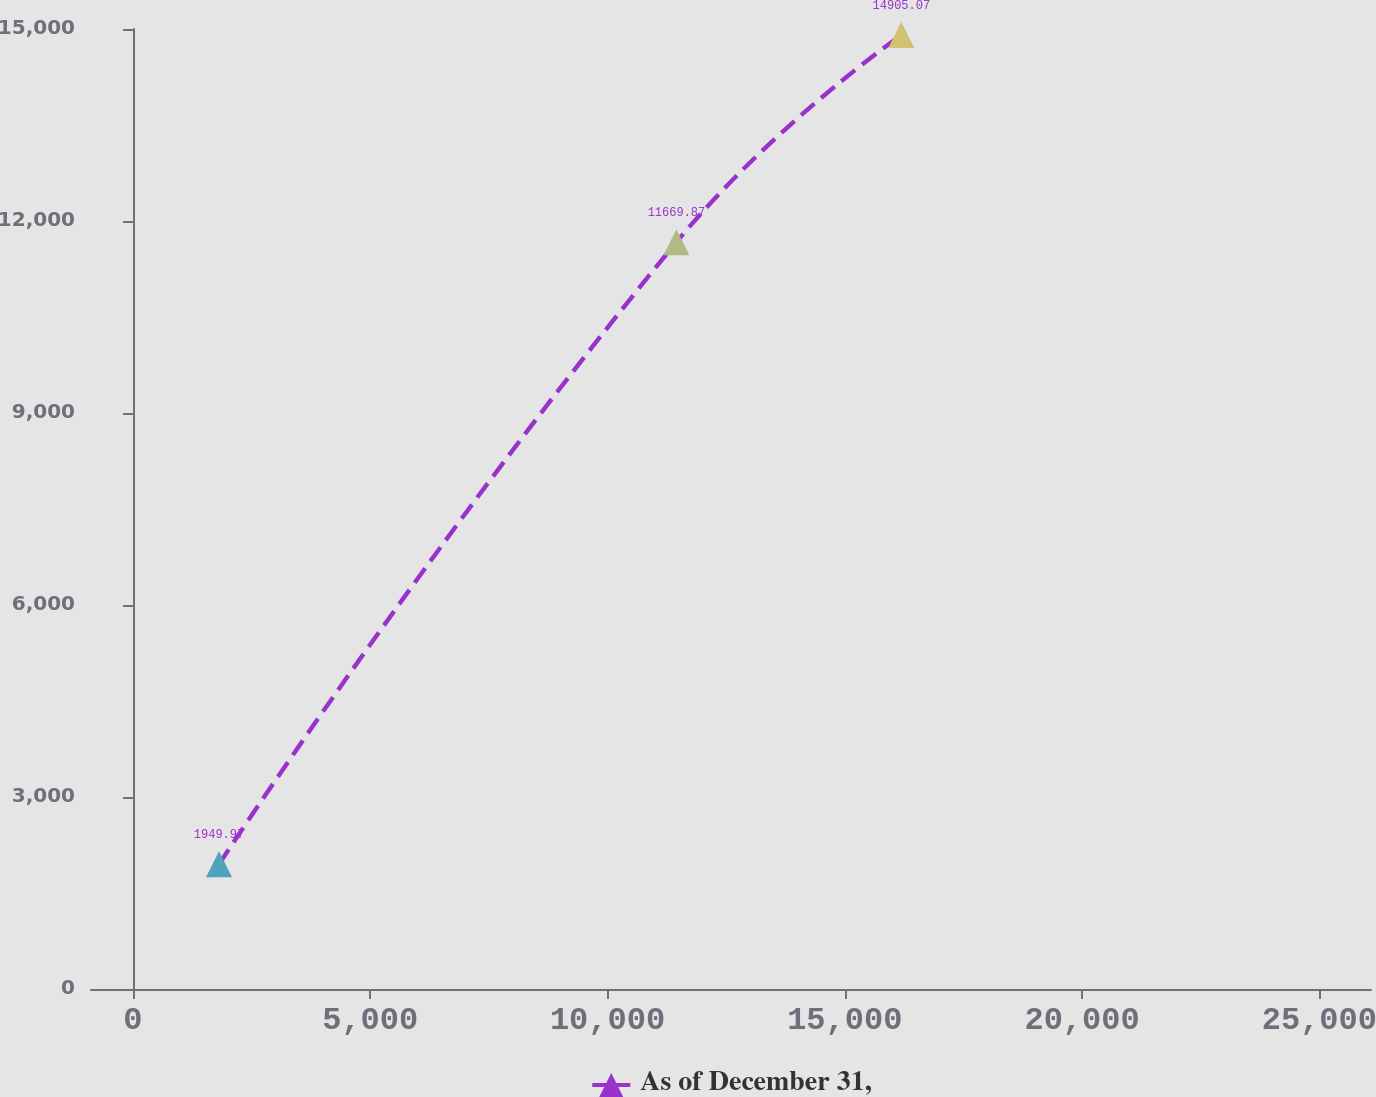Convert chart. <chart><loc_0><loc_0><loc_500><loc_500><line_chart><ecel><fcel>As of December 31,<nl><fcel>1814.01<fcel>1949.97<nl><fcel>11453.2<fcel>11669.9<nl><fcel>16192<fcel>14905.1<nl><fcel>28785.7<fcel>32809.5<nl></chart> 